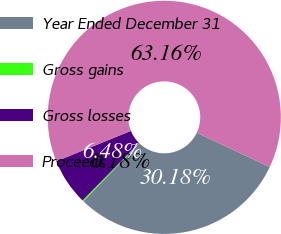<chart> <loc_0><loc_0><loc_500><loc_500><pie_chart><fcel>Year Ended December 31<fcel>Gross gains<fcel>Gross losses<fcel>Proceeds<nl><fcel>30.18%<fcel>0.18%<fcel>6.48%<fcel>63.16%<nl></chart> 